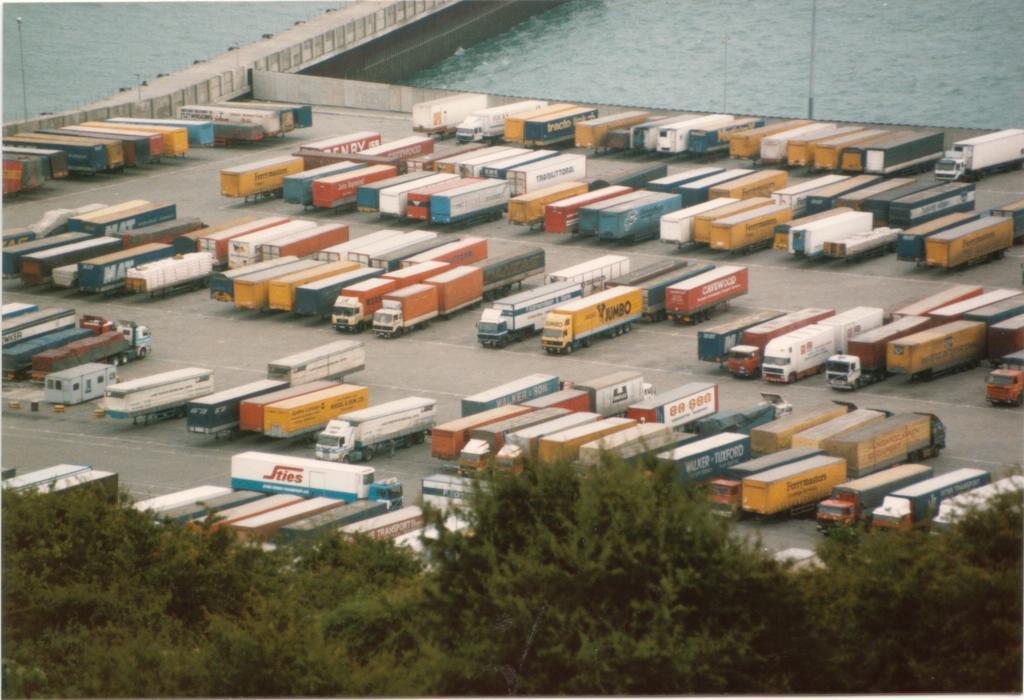Can you describe this image briefly? In this image I can see many trees and the vehicles. I can see these vehicles are colorful. In the background I can see the poles, road and the water. 